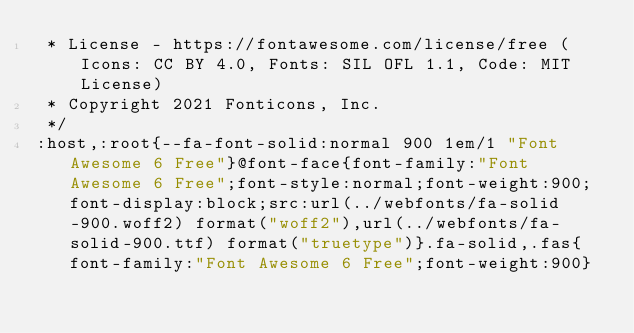<code> <loc_0><loc_0><loc_500><loc_500><_CSS_> * License - https://fontawesome.com/license/free (Icons: CC BY 4.0, Fonts: SIL OFL 1.1, Code: MIT License)
 * Copyright 2021 Fonticons, Inc.
 */
:host,:root{--fa-font-solid:normal 900 1em/1 "Font Awesome 6 Free"}@font-face{font-family:"Font Awesome 6 Free";font-style:normal;font-weight:900;font-display:block;src:url(../webfonts/fa-solid-900.woff2) format("woff2"),url(../webfonts/fa-solid-900.ttf) format("truetype")}.fa-solid,.fas{font-family:"Font Awesome 6 Free";font-weight:900}</code> 